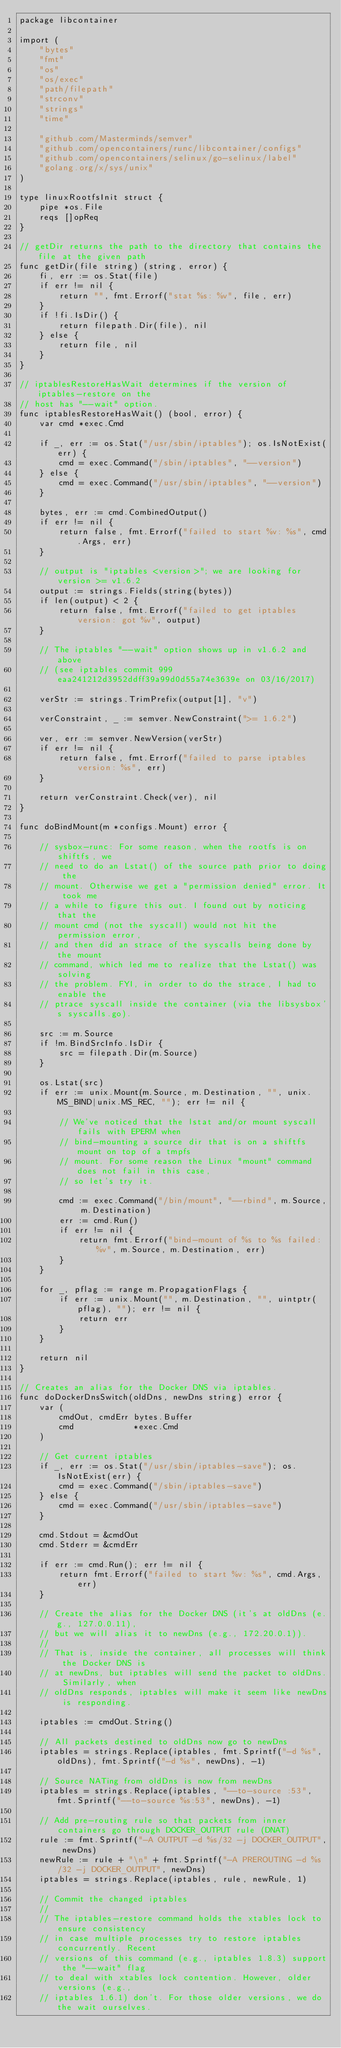Convert code to text. <code><loc_0><loc_0><loc_500><loc_500><_Go_>package libcontainer

import (
	"bytes"
	"fmt"
	"os"
	"os/exec"
	"path/filepath"
	"strconv"
	"strings"
	"time"

	"github.com/Masterminds/semver"
	"github.com/opencontainers/runc/libcontainer/configs"
	"github.com/opencontainers/selinux/go-selinux/label"
	"golang.org/x/sys/unix"
)

type linuxRootfsInit struct {
	pipe *os.File
	reqs []opReq
}

// getDir returns the path to the directory that contains the file at the given path
func getDir(file string) (string, error) {
	fi, err := os.Stat(file)
	if err != nil {
		return "", fmt.Errorf("stat %s: %v", file, err)
	}
	if !fi.IsDir() {
		return filepath.Dir(file), nil
	} else {
		return file, nil
	}
}

// iptablesRestoreHasWait determines if the version of iptables-restore on the
// host has "--wait" option.
func iptablesRestoreHasWait() (bool, error) {
	var cmd *exec.Cmd

	if _, err := os.Stat("/usr/sbin/iptables"); os.IsNotExist(err) {
		cmd = exec.Command("/sbin/iptables", "--version")
	} else {
		cmd = exec.Command("/usr/sbin/iptables", "--version")
	}

	bytes, err := cmd.CombinedOutput()
	if err != nil {
		return false, fmt.Errorf("failed to start %v: %s", cmd.Args, err)
	}

	// output is "iptables <version>"; we are looking for version >= v1.6.2
	output := strings.Fields(string(bytes))
	if len(output) < 2 {
		return false, fmt.Errorf("failed to get iptables version: got %v", output)
	}

	// The iptables "--wait" option shows up in v1.6.2 and above
	// (see iptables commit 999eaa241212d3952ddff39a99d0d55a74e3639e on 03/16/2017)

	verStr := strings.TrimPrefix(output[1], "v")

	verConstraint, _ := semver.NewConstraint(">= 1.6.2")

	ver, err := semver.NewVersion(verStr)
	if err != nil {
		return false, fmt.Errorf("failed to parse iptables version: %s", err)
	}

	return verConstraint.Check(ver), nil
}

func doBindMount(m *configs.Mount) error {

	// sysbox-runc: For some reason, when the rootfs is on shiftfs, we
	// need to do an Lstat() of the source path prior to doing the
	// mount. Otherwise we get a "permission denied" error. It took me
	// a while to figure this out. I found out by noticing that the
	// mount cmd (not the syscall) would not hit the permission error,
	// and then did an strace of the syscalls being done by the mount
	// command, which led me to realize that the Lstat() was solving
	// the problem. FYI, in order to do the strace, I had to enable the
	// ptrace syscall inside the container (via the libsysbox's syscalls.go).

	src := m.Source
	if !m.BindSrcInfo.IsDir {
		src = filepath.Dir(m.Source)
	}

	os.Lstat(src)
	if err := unix.Mount(m.Source, m.Destination, "", unix.MS_BIND|unix.MS_REC, ""); err != nil {

		// We've noticed that the lstat and/or mount syscall fails with EPERM when
		// bind-mounting a source dir that is on a shiftfs mount on top of a tmpfs
		// mount. For some reason the Linux "mount" command does not fail in this case,
		// so let's try it.

		cmd := exec.Command("/bin/mount", "--rbind", m.Source, m.Destination)
		err := cmd.Run()
		if err != nil {
			return fmt.Errorf("bind-mount of %s to %s failed: %v", m.Source, m.Destination, err)
		}
	}

	for _, pflag := range m.PropagationFlags {
		if err := unix.Mount("", m.Destination, "", uintptr(pflag), ""); err != nil {
			return err
		}
	}

	return nil
}

// Creates an alias for the Docker DNS via iptables.
func doDockerDnsSwitch(oldDns, newDns string) error {
	var (
		cmdOut, cmdErr bytes.Buffer
		cmd            *exec.Cmd
	)

	// Get current iptables
	if _, err := os.Stat("/usr/sbin/iptables-save"); os.IsNotExist(err) {
		cmd = exec.Command("/sbin/iptables-save")
	} else {
		cmd = exec.Command("/usr/sbin/iptables-save")
	}

	cmd.Stdout = &cmdOut
	cmd.Stderr = &cmdErr

	if err := cmd.Run(); err != nil {
		return fmt.Errorf("failed to start %v: %s", cmd.Args, err)
	}

	// Create the alias for the Docker DNS (it's at oldDns (e.g., 127.0.0.11),
	// but we will alias it to newDns (e.g., 172.20.0.1)).
	//
	// That is, inside the container, all processes will think the Docker DNS is
	// at newDns, but iptables will send the packet to oldDns. Similarly, when
	// oldDns responds, iptables will make it seem like newDns is responding.

	iptables := cmdOut.String()

	// All packets destined to oldDns now go to newDns
	iptables = strings.Replace(iptables, fmt.Sprintf("-d %s", oldDns), fmt.Sprintf("-d %s", newDns), -1)

	// Source NATing from oldDns is now from newDns
	iptables = strings.Replace(iptables, "--to-source :53", fmt.Sprintf("--to-source %s:53", newDns), -1)

	// Add pre-routing rule so that packets from inner containers go through DOCKER_OUTPUT rule (DNAT)
	rule := fmt.Sprintf("-A OUTPUT -d %s/32 -j DOCKER_OUTPUT", newDns)
	newRule := rule + "\n" + fmt.Sprintf("-A PREROUTING -d %s/32 -j DOCKER_OUTPUT", newDns)
	iptables = strings.Replace(iptables, rule, newRule, 1)

	// Commit the changed iptables
	//
	// The iptables-restore command holds the xtables lock to ensure consistency
	// in case multiple processes try to restore iptables concurrently. Recent
	// versions of this command (e.g., iptables 1.8.3) support the "--wait" flag
	// to deal with xtables lock contention. However, older versions (e.g.,
	// iptables 1.6.1) don't. For those older versions, we do the wait ourselves.
</code> 